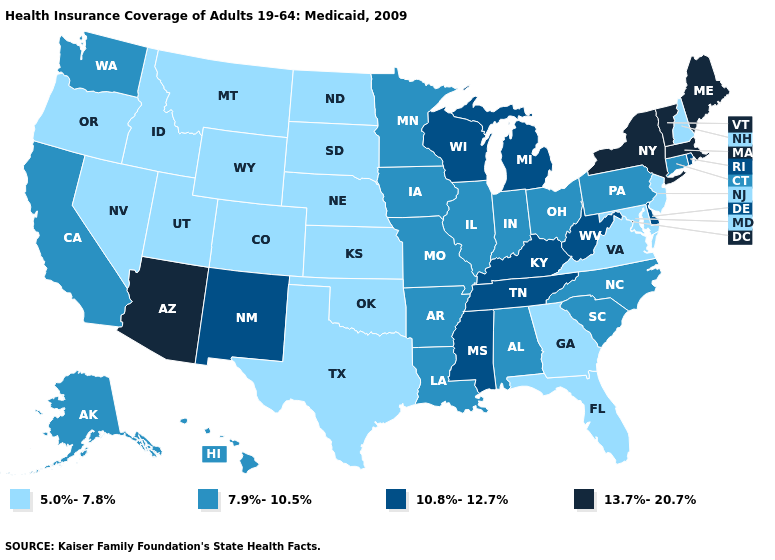What is the highest value in the South ?
Quick response, please. 10.8%-12.7%. What is the value of Kansas?
Short answer required. 5.0%-7.8%. Does Mississippi have the lowest value in the USA?
Answer briefly. No. Name the states that have a value in the range 13.7%-20.7%?
Concise answer only. Arizona, Maine, Massachusetts, New York, Vermont. Name the states that have a value in the range 7.9%-10.5%?
Give a very brief answer. Alabama, Alaska, Arkansas, California, Connecticut, Hawaii, Illinois, Indiana, Iowa, Louisiana, Minnesota, Missouri, North Carolina, Ohio, Pennsylvania, South Carolina, Washington. What is the value of New Jersey?
Concise answer only. 5.0%-7.8%. Which states have the lowest value in the USA?
Answer briefly. Colorado, Florida, Georgia, Idaho, Kansas, Maryland, Montana, Nebraska, Nevada, New Hampshire, New Jersey, North Dakota, Oklahoma, Oregon, South Dakota, Texas, Utah, Virginia, Wyoming. Name the states that have a value in the range 10.8%-12.7%?
Short answer required. Delaware, Kentucky, Michigan, Mississippi, New Mexico, Rhode Island, Tennessee, West Virginia, Wisconsin. Does the first symbol in the legend represent the smallest category?
Write a very short answer. Yes. What is the value of Arkansas?
Give a very brief answer. 7.9%-10.5%. Does New Jersey have the lowest value in the USA?
Quick response, please. Yes. What is the value of Alabama?
Concise answer only. 7.9%-10.5%. Name the states that have a value in the range 7.9%-10.5%?
Write a very short answer. Alabama, Alaska, Arkansas, California, Connecticut, Hawaii, Illinois, Indiana, Iowa, Louisiana, Minnesota, Missouri, North Carolina, Ohio, Pennsylvania, South Carolina, Washington. Which states have the highest value in the USA?
Answer briefly. Arizona, Maine, Massachusetts, New York, Vermont. Name the states that have a value in the range 5.0%-7.8%?
Concise answer only. Colorado, Florida, Georgia, Idaho, Kansas, Maryland, Montana, Nebraska, Nevada, New Hampshire, New Jersey, North Dakota, Oklahoma, Oregon, South Dakota, Texas, Utah, Virginia, Wyoming. 